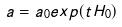Convert formula to latex. <formula><loc_0><loc_0><loc_500><loc_500>a = a _ { 0 } e x p ( t H _ { 0 } )</formula> 